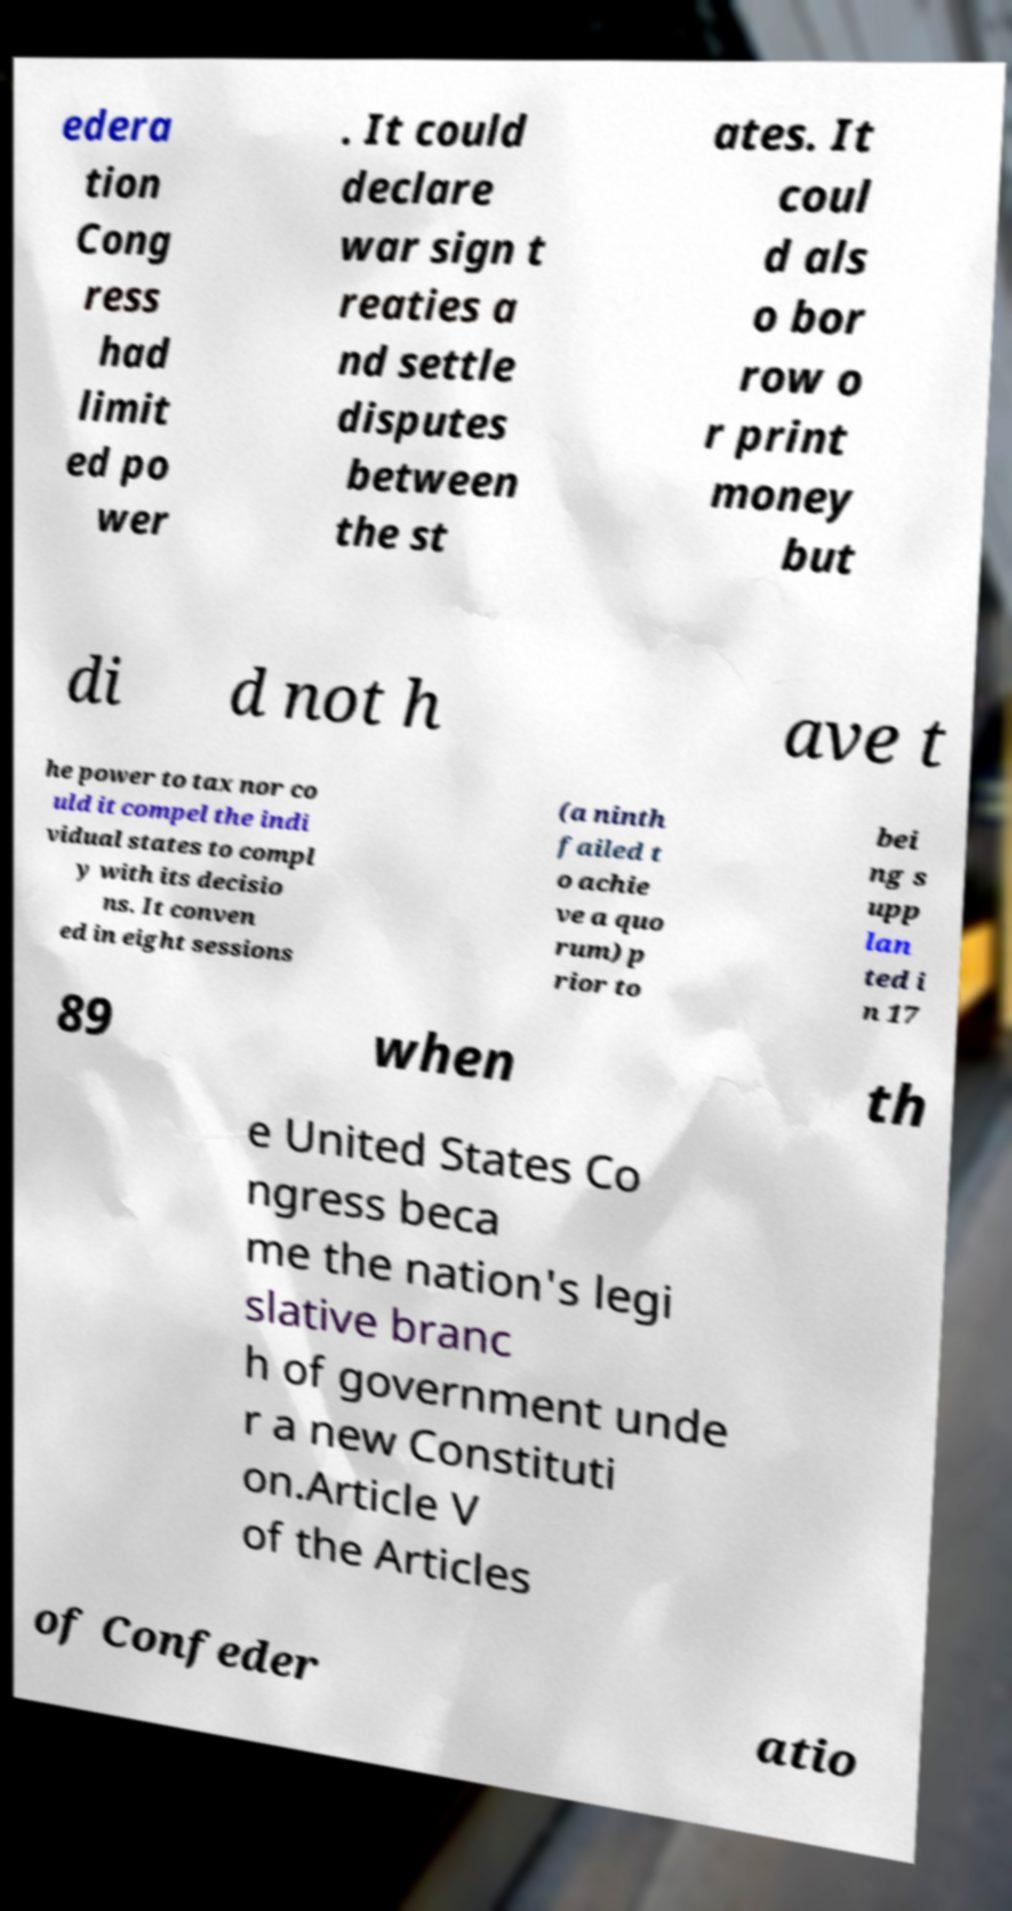Could you extract and type out the text from this image? edera tion Cong ress had limit ed po wer . It could declare war sign t reaties a nd settle disputes between the st ates. It coul d als o bor row o r print money but di d not h ave t he power to tax nor co uld it compel the indi vidual states to compl y with its decisio ns. It conven ed in eight sessions (a ninth failed t o achie ve a quo rum) p rior to bei ng s upp lan ted i n 17 89 when th e United States Co ngress beca me the nation's legi slative branc h of government unde r a new Constituti on.Article V of the Articles of Confeder atio 